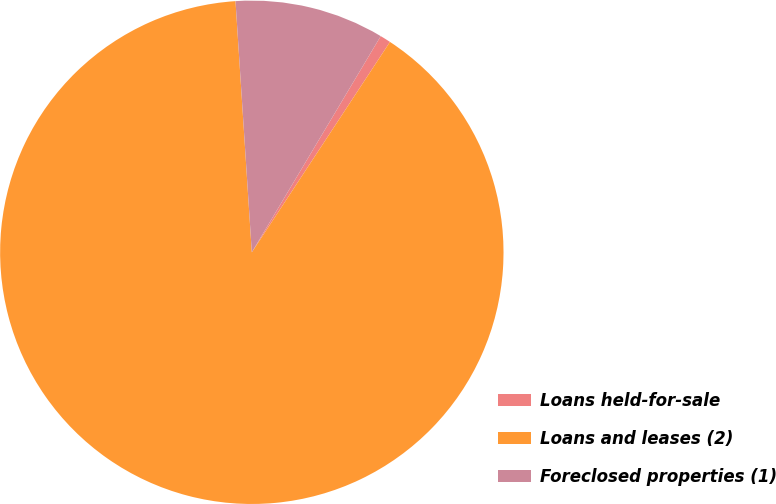Convert chart. <chart><loc_0><loc_0><loc_500><loc_500><pie_chart><fcel>Loans held-for-sale<fcel>Loans and leases (2)<fcel>Foreclosed properties (1)<nl><fcel>0.69%<fcel>89.72%<fcel>9.59%<nl></chart> 